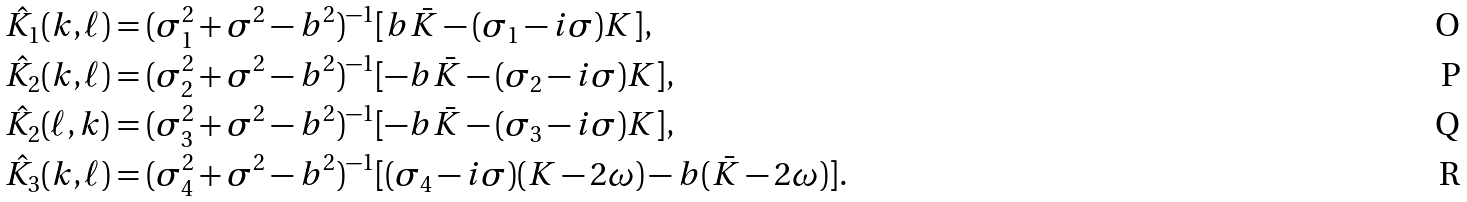Convert formula to latex. <formula><loc_0><loc_0><loc_500><loc_500>\hat { K } _ { 1 } ( k , \ell ) & = ( \sigma ^ { 2 } _ { 1 } + \sigma ^ { 2 } - b ^ { 2 } ) ^ { - 1 } [ b \bar { K } - ( \sigma _ { 1 } - i \sigma ) K ] , \\ \hat { K } _ { 2 } ( k , \ell ) & = ( \sigma ^ { 2 } _ { 2 } + \sigma ^ { 2 } - b ^ { 2 } ) ^ { - 1 } [ - b \bar { K } - ( \sigma _ { 2 } - i \sigma ) K ] , \\ \hat { K } _ { 2 } ( \ell , k ) & = ( \sigma ^ { 2 } _ { 3 } + \sigma ^ { 2 } - b ^ { 2 } ) ^ { - 1 } [ - b \bar { K } - ( \sigma _ { 3 } - i \sigma ) K ] , \\ \hat { K } _ { 3 } ( k , \ell ) & = ( \sigma ^ { 2 } _ { 4 } + \sigma ^ { 2 } - b ^ { 2 } ) ^ { - 1 } [ ( \sigma _ { 4 } - i \sigma ) ( K - 2 \omega ) - b ( \bar { K } - 2 \omega ) ] .</formula> 